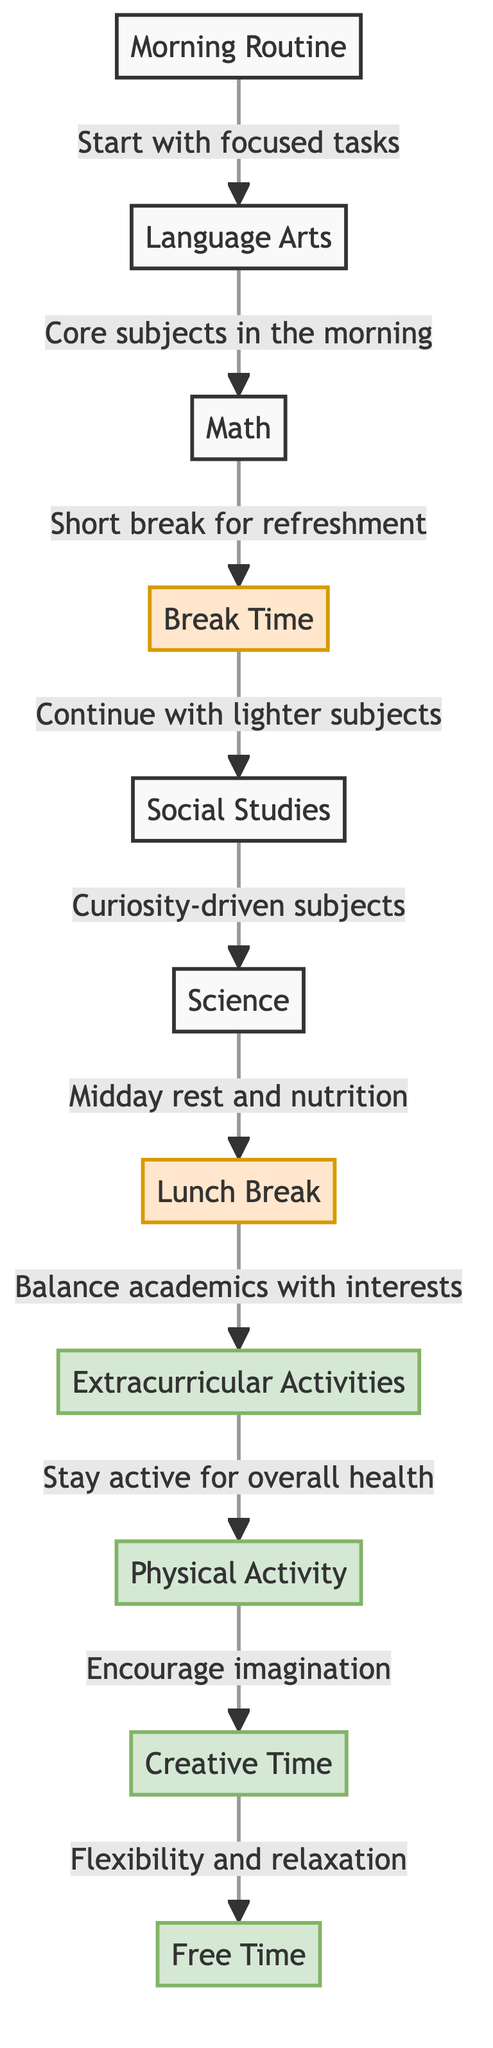What is the first activity listed in the diagram? The first activity is "Morning Routine", which is represented as the initial node in the flowchart. This is where the daily schedule begins.
Answer: Morning Routine How many break periods are included in the schedule? The diagram shows two break periods: "Break Time" and "Lunch Break", which are distinct nodes labeled as breaks.
Answer: 2 What activity follows "Math"? After "Math", the next node in the diagram is "Break Time". This indicates that a break follows the math session.
Answer: Break Time Which activities are categorized as extracurricular? In the diagram, "Extracurricular Activities" is identified as a specific activity, where students engage in interests outside of core subjects.
Answer: Extracurricular Activities What is the main purpose of the "Free Time" activity? "Free Time" serves as a period of flexibility and relaxation for students after all core academic and activity sessions, as indicated by its description in the diagram.
Answer: Flexibility and relaxation Which subject comes after "Social Studies" in the daily schedule? Following "Social Studies", the next subject listed is "Science", as the arrows connect these nodes sequentially in the diagram.
Answer: Science How is physical activity positioned in the daily schedule? "Physical Activity" comes after "Extracurricular Activities" in the flowchart, highlighting its role as an ongoing component for overall health in the learning routine.
Answer: After Extracurricular Activities What does the "Lunch" node connect to in the diagram? The "Lunch" node connects to the "Extracurricular Activities" node, indicating that students balance academics with interests after having their lunch.
Answer: Extracurricular Activities What type of subjects are indicated after the break time? After "Break Time", the diagram indicates a transition to "Social Studies", which is described as curiosity-driven subjects.
Answer: Curiosity-driven subjects 